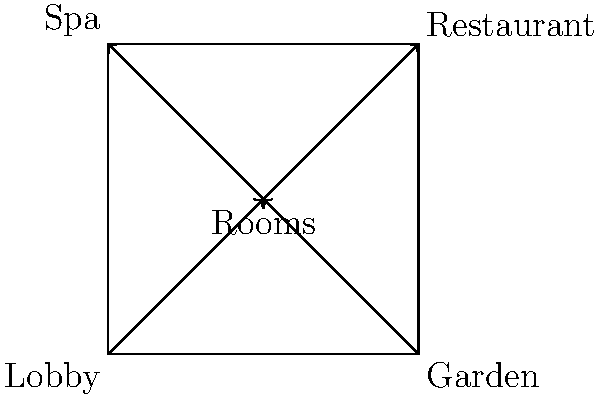Based on the simplified map of your boutique hotel, which path maximizes guest flow and experience by ensuring they pass through the most amenities before reaching their rooms? To determine the optimal path for guest flow, we need to consider the following steps:

1. Identify the starting point: The lobby is typically the entry point for guests, located at point A.

2. Analyze the available paths:
   a. Lobby (A) → Rooms (E)
   b. Lobby (A) → Garden (B) → Rooms (E)
   c. Lobby (A) → Rooms (E) → Restaurant (C)
   d. Lobby (A) → Rooms (E) → Spa (D)

3. Consider the guest experience:
   - Passing through the garden before reaching the rooms allows guests to appreciate the historic mansion's exterior.
   - The restaurant and spa are amenities that guests might use after checking in.

4. Evaluate the flow:
   - The path Lobby (A) → Garden (B) → Rooms (E) allows guests to experience two areas before reaching their rooms.
   - This path doesn't force guests through the restaurant or spa, which they may not want to visit immediately upon arrival.

5. Future movements:
   - From the rooms, guests can easily access the restaurant (E → C) or spa (E → D) as desired.

Therefore, the optimal path for maximizing guest flow and experience while ensuring they pass through the most appropriate amenities before reaching their rooms is:

Lobby (A) → Garden (B) → Rooms (E)

This path showcases the property's exterior, doesn't overwhelm guests with too many stops before reaching their rooms, and positions them centrally for easy access to other amenities later in their stay.
Answer: Lobby → Garden → Rooms 